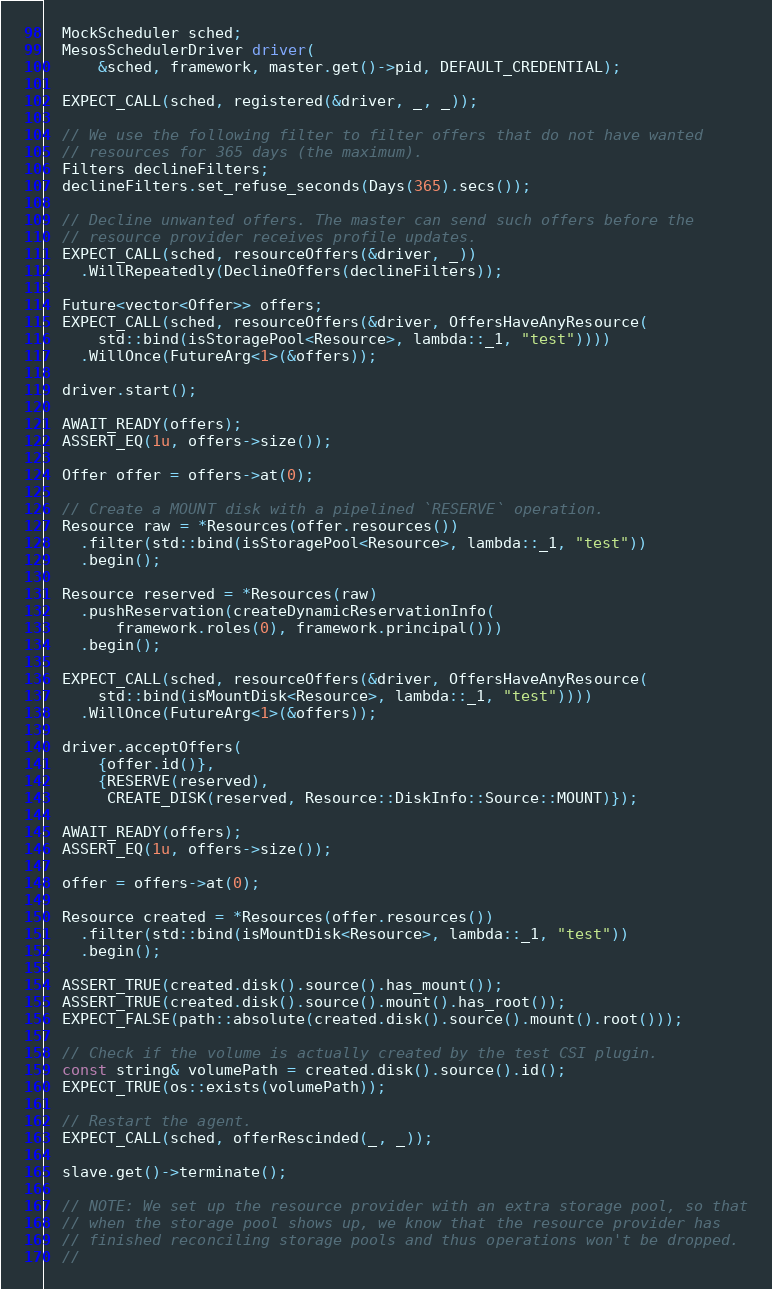<code> <loc_0><loc_0><loc_500><loc_500><_C++_>
  MockScheduler sched;
  MesosSchedulerDriver driver(
      &sched, framework, master.get()->pid, DEFAULT_CREDENTIAL);

  EXPECT_CALL(sched, registered(&driver, _, _));

  // We use the following filter to filter offers that do not have wanted
  // resources for 365 days (the maximum).
  Filters declineFilters;
  declineFilters.set_refuse_seconds(Days(365).secs());

  // Decline unwanted offers. The master can send such offers before the
  // resource provider receives profile updates.
  EXPECT_CALL(sched, resourceOffers(&driver, _))
    .WillRepeatedly(DeclineOffers(declineFilters));

  Future<vector<Offer>> offers;
  EXPECT_CALL(sched, resourceOffers(&driver, OffersHaveAnyResource(
      std::bind(isStoragePool<Resource>, lambda::_1, "test"))))
    .WillOnce(FutureArg<1>(&offers));

  driver.start();

  AWAIT_READY(offers);
  ASSERT_EQ(1u, offers->size());

  Offer offer = offers->at(0);

  // Create a MOUNT disk with a pipelined `RESERVE` operation.
  Resource raw = *Resources(offer.resources())
    .filter(std::bind(isStoragePool<Resource>, lambda::_1, "test"))
    .begin();

  Resource reserved = *Resources(raw)
    .pushReservation(createDynamicReservationInfo(
        framework.roles(0), framework.principal()))
    .begin();

  EXPECT_CALL(sched, resourceOffers(&driver, OffersHaveAnyResource(
      std::bind(isMountDisk<Resource>, lambda::_1, "test"))))
    .WillOnce(FutureArg<1>(&offers));

  driver.acceptOffers(
      {offer.id()},
      {RESERVE(reserved),
       CREATE_DISK(reserved, Resource::DiskInfo::Source::MOUNT)});

  AWAIT_READY(offers);
  ASSERT_EQ(1u, offers->size());

  offer = offers->at(0);

  Resource created = *Resources(offer.resources())
    .filter(std::bind(isMountDisk<Resource>, lambda::_1, "test"))
    .begin();

  ASSERT_TRUE(created.disk().source().has_mount());
  ASSERT_TRUE(created.disk().source().mount().has_root());
  EXPECT_FALSE(path::absolute(created.disk().source().mount().root()));

  // Check if the volume is actually created by the test CSI plugin.
  const string& volumePath = created.disk().source().id();
  EXPECT_TRUE(os::exists(volumePath));

  // Restart the agent.
  EXPECT_CALL(sched, offerRescinded(_, _));

  slave.get()->terminate();

  // NOTE: We set up the resource provider with an extra storage pool, so that
  // when the storage pool shows up, we know that the resource provider has
  // finished reconciling storage pools and thus operations won't be dropped.
  //</code> 